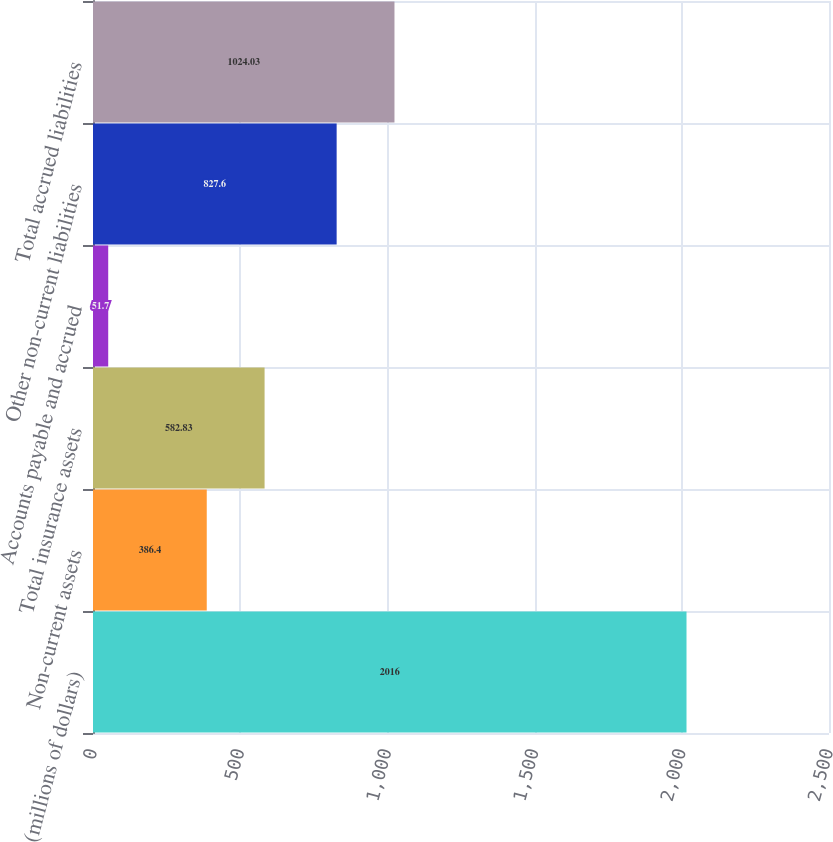Convert chart to OTSL. <chart><loc_0><loc_0><loc_500><loc_500><bar_chart><fcel>(millions of dollars)<fcel>Non-current assets<fcel>Total insurance assets<fcel>Accounts payable and accrued<fcel>Other non-current liabilities<fcel>Total accrued liabilities<nl><fcel>2016<fcel>386.4<fcel>582.83<fcel>51.7<fcel>827.6<fcel>1024.03<nl></chart> 